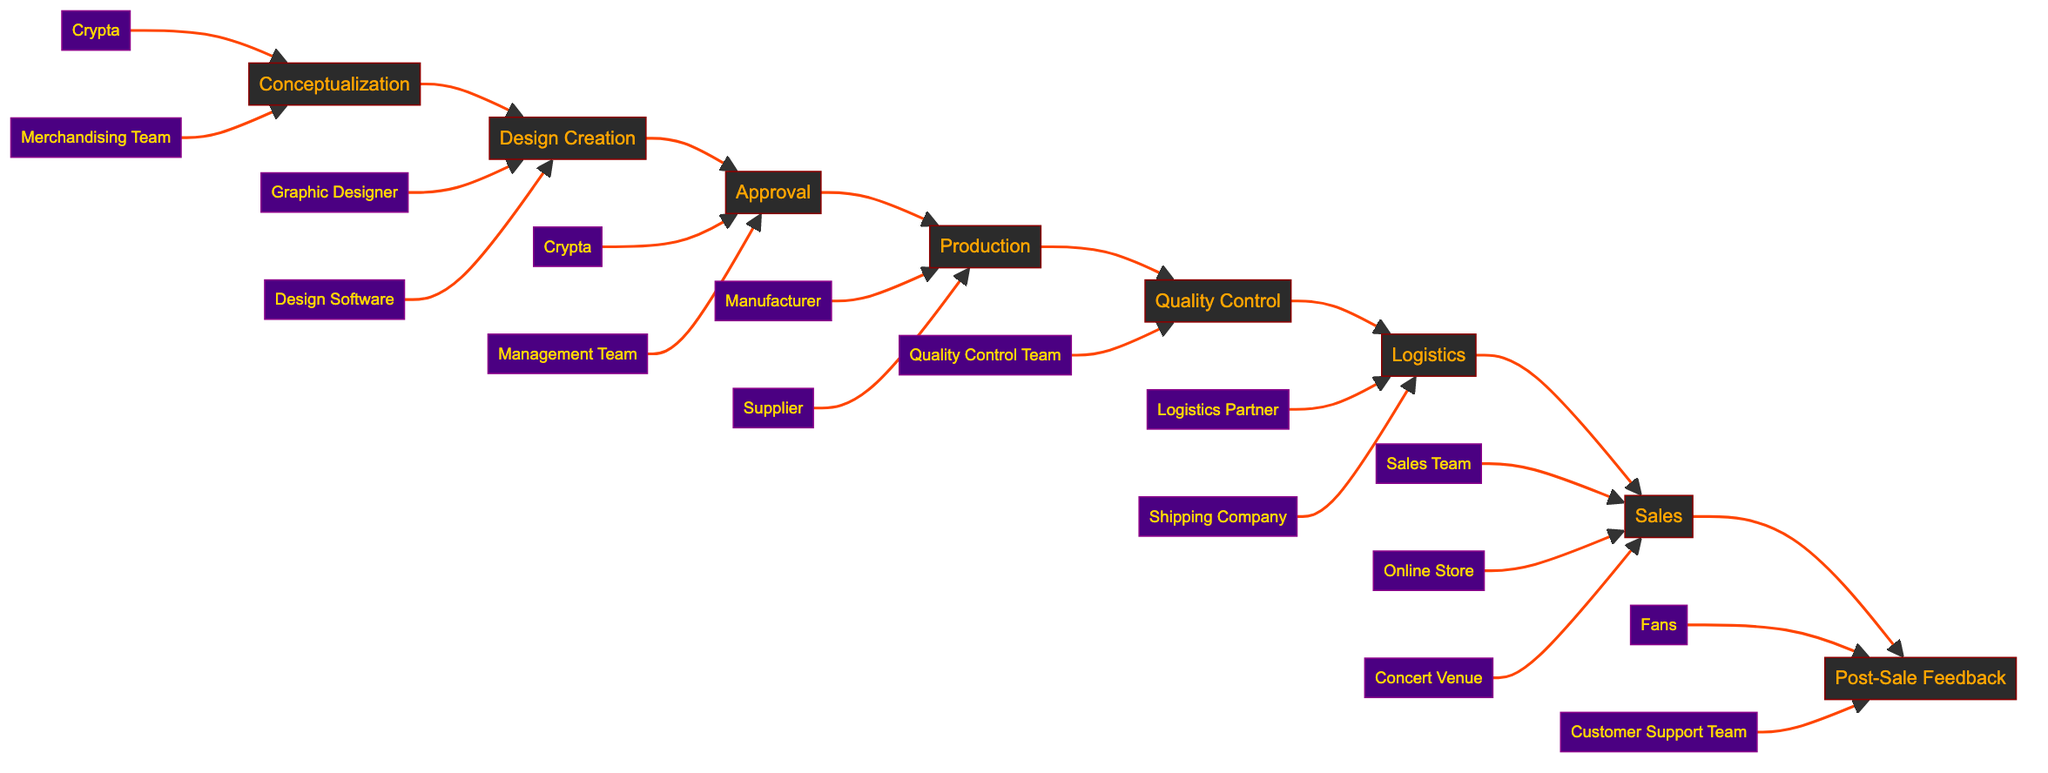What's the first stage of the merchandise life cycle? The diagram starts with the "Conceptualization" stage, which is the first step where ideas are brainstormed.
Answer: Conceptualization How many total stages are there in the life cycle? Counting the stages from "Conceptualization" to "Post-Sale Feedback," there are a total of eight stages.
Answer: 8 Which entities are involved in the "Design Creation" stage? The entities listed under "Design Creation" are the "Graphic Designer" and "Design Software," indicating who is responsible for creating the designs.
Answer: Graphic Designer, Design Software What comes after "Approval" in the flowchart? The flowchart shows that after "Approval," the next stage is "Production," where approved designs are sent for manufacturing.
Answer: Production What is the last stage in the merchandise life cycle? The final stage listed in the flowchart is "Post-Sale Feedback," which involves collecting feedback from fans after merchandise sales.
Answer: Post-Sale Feedback Which two entities are involved in the "Logistics" stage? In the "Logistics" stage, the entities are the "Logistics Partner" and the "Shipping Company," responsible for shipping the merchandise to the concert venue and online store.
Answer: Logistics Partner, Shipping Company Which stage involves fans providing feedback? The "Post-Sale Feedback" stage is specifically focused on collecting feedback from fans regarding their experience with the merchandise.
Answer: Post-Sale Feedback What is the main purpose of the "Quality Control" stage? The "Quality Control" stage ensures that the produced merchandise meets the required standards through thorough checks before they are sent out.
Answer: Quality checks What stage follows "Sales" in the life cycle? The flowchart indicates that "Post-Sale Feedback" follows the "Sales" stage, suggesting a sequence from selling to collecting feedback.
Answer: Post-Sale Feedback 